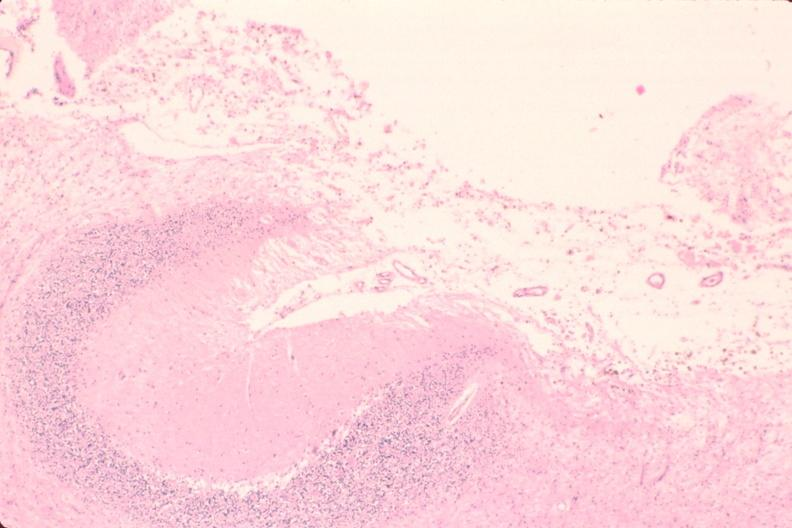s nervous present?
Answer the question using a single word or phrase. Yes 